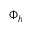Convert formula to latex. <formula><loc_0><loc_0><loc_500><loc_500>\Phi _ { h }</formula> 